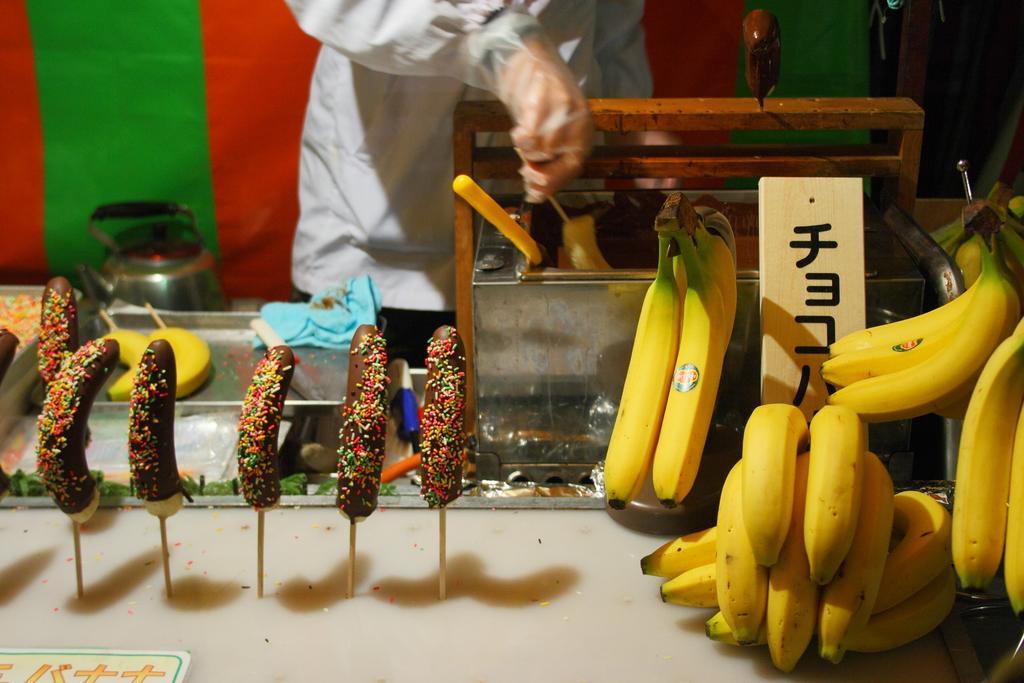How would you summarize this image in a sentence or two? In this image there are bananas on the right side. In the background there is a man who is dipping the bananas in the cream. On the left side there are bananas on which there is cream and some gems on it. On the right side top there is a curtain. At the bottom there is cream. 